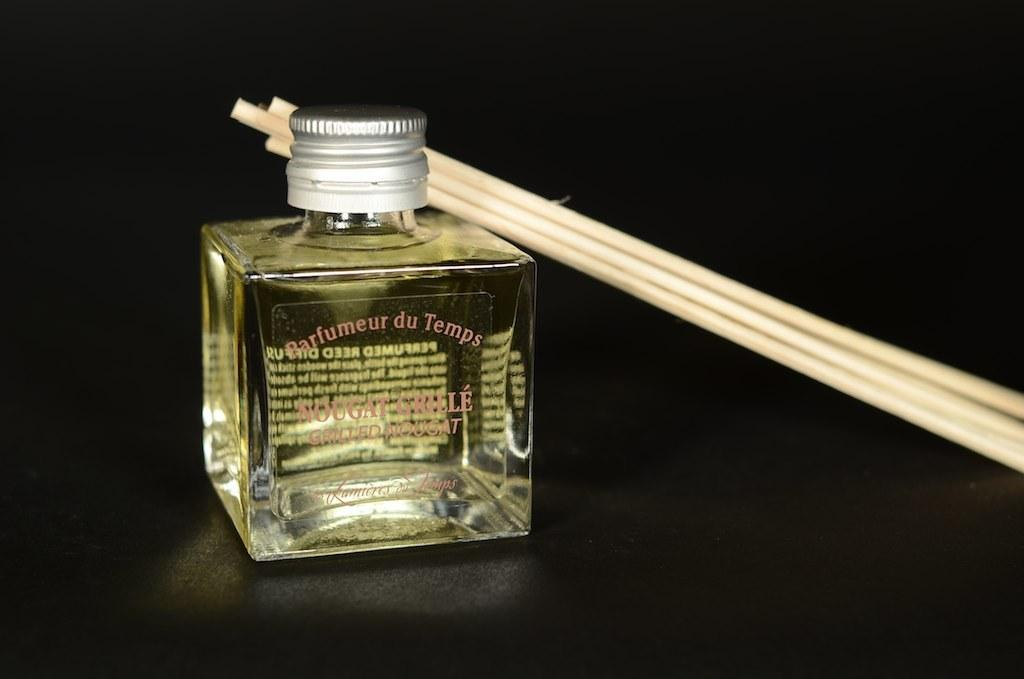<image>
Write a terse but informative summary of the picture. A bottle on a table labeled Barfumeur du Temps with sticks leaning on it. 